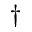Convert formula to latex. <formula><loc_0><loc_0><loc_500><loc_500>^ { \dag }</formula> 